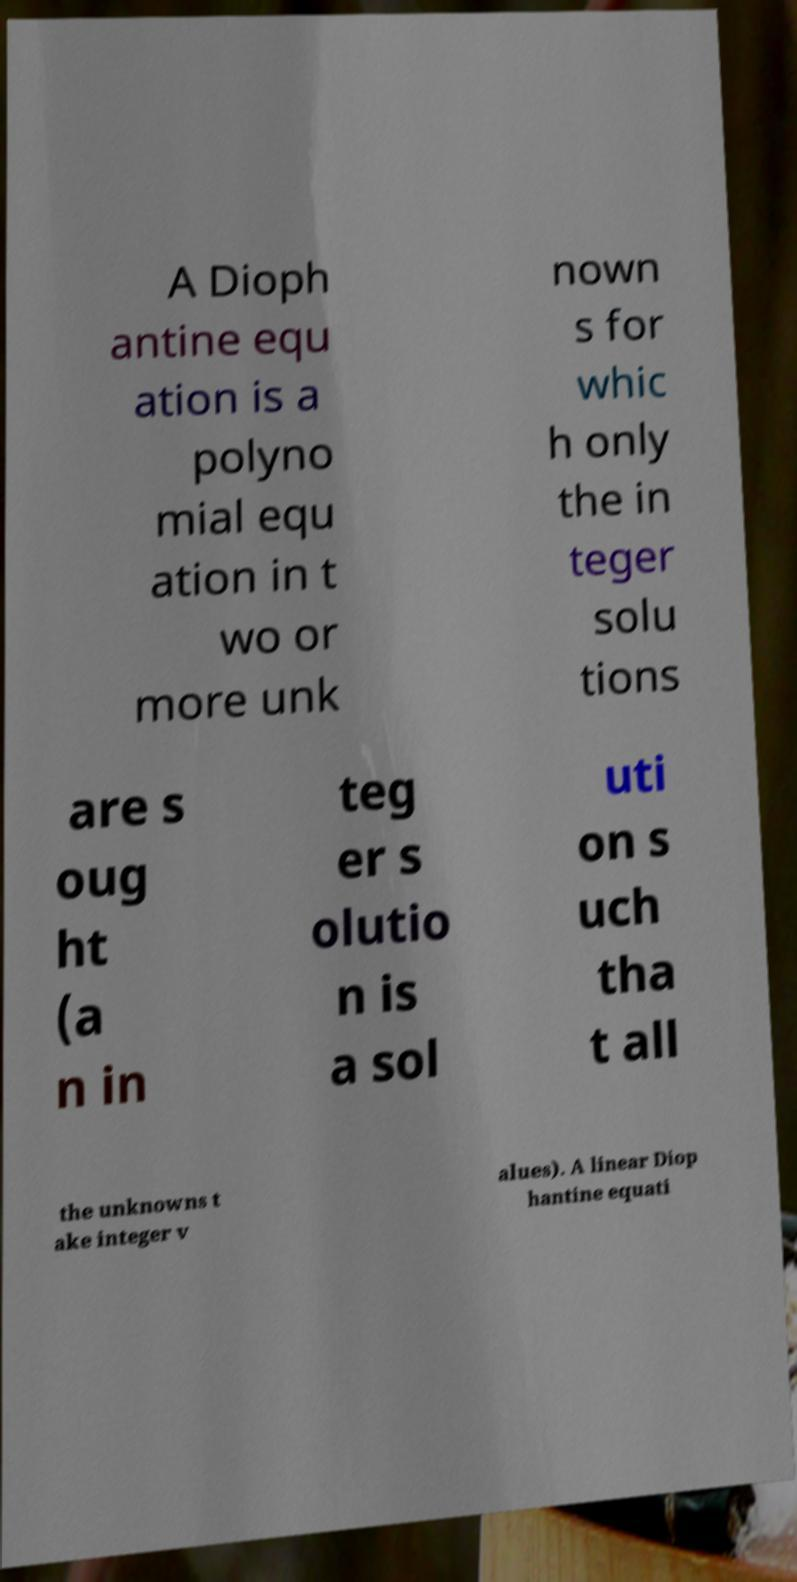Please identify and transcribe the text found in this image. A Dioph antine equ ation is a polyno mial equ ation in t wo or more unk nown s for whic h only the in teger solu tions are s oug ht (a n in teg er s olutio n is a sol uti on s uch tha t all the unknowns t ake integer v alues). A linear Diop hantine equati 